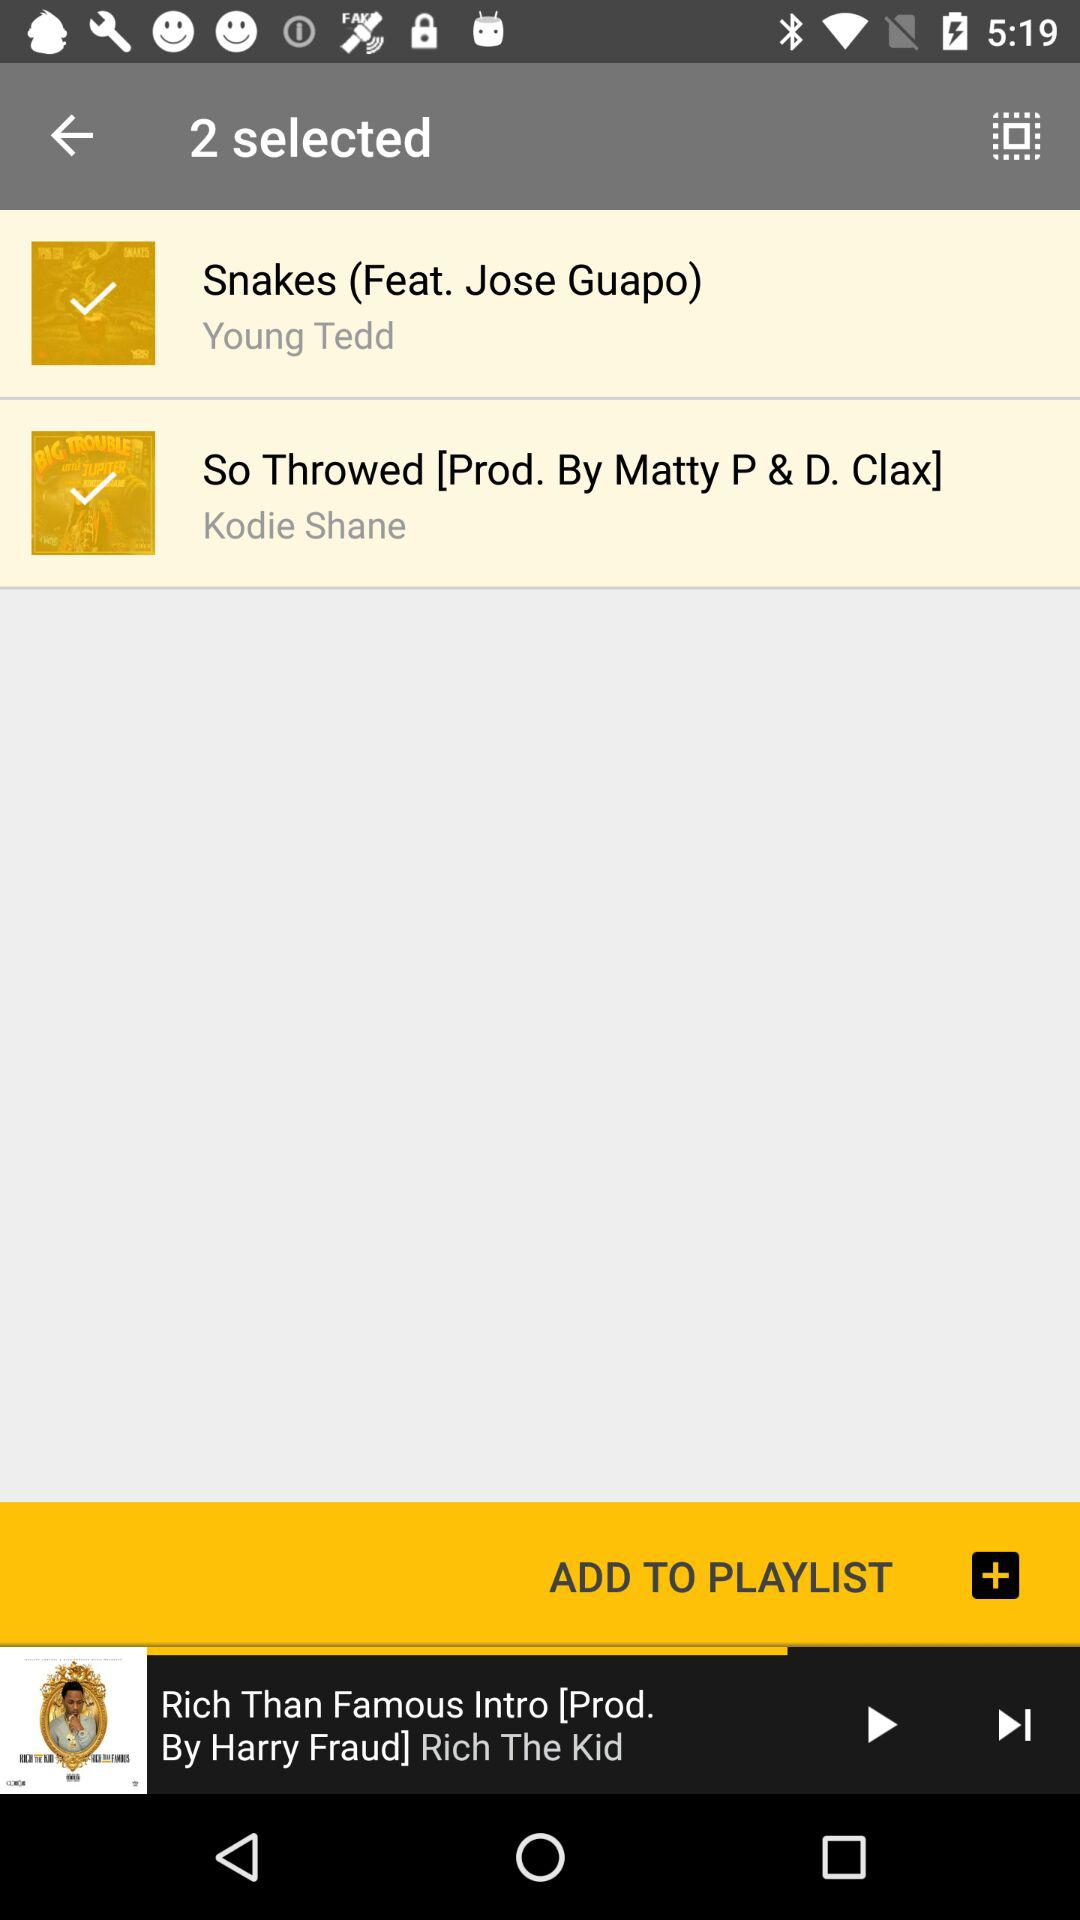How many songs are selected?
Answer the question using a single word or phrase. 2 